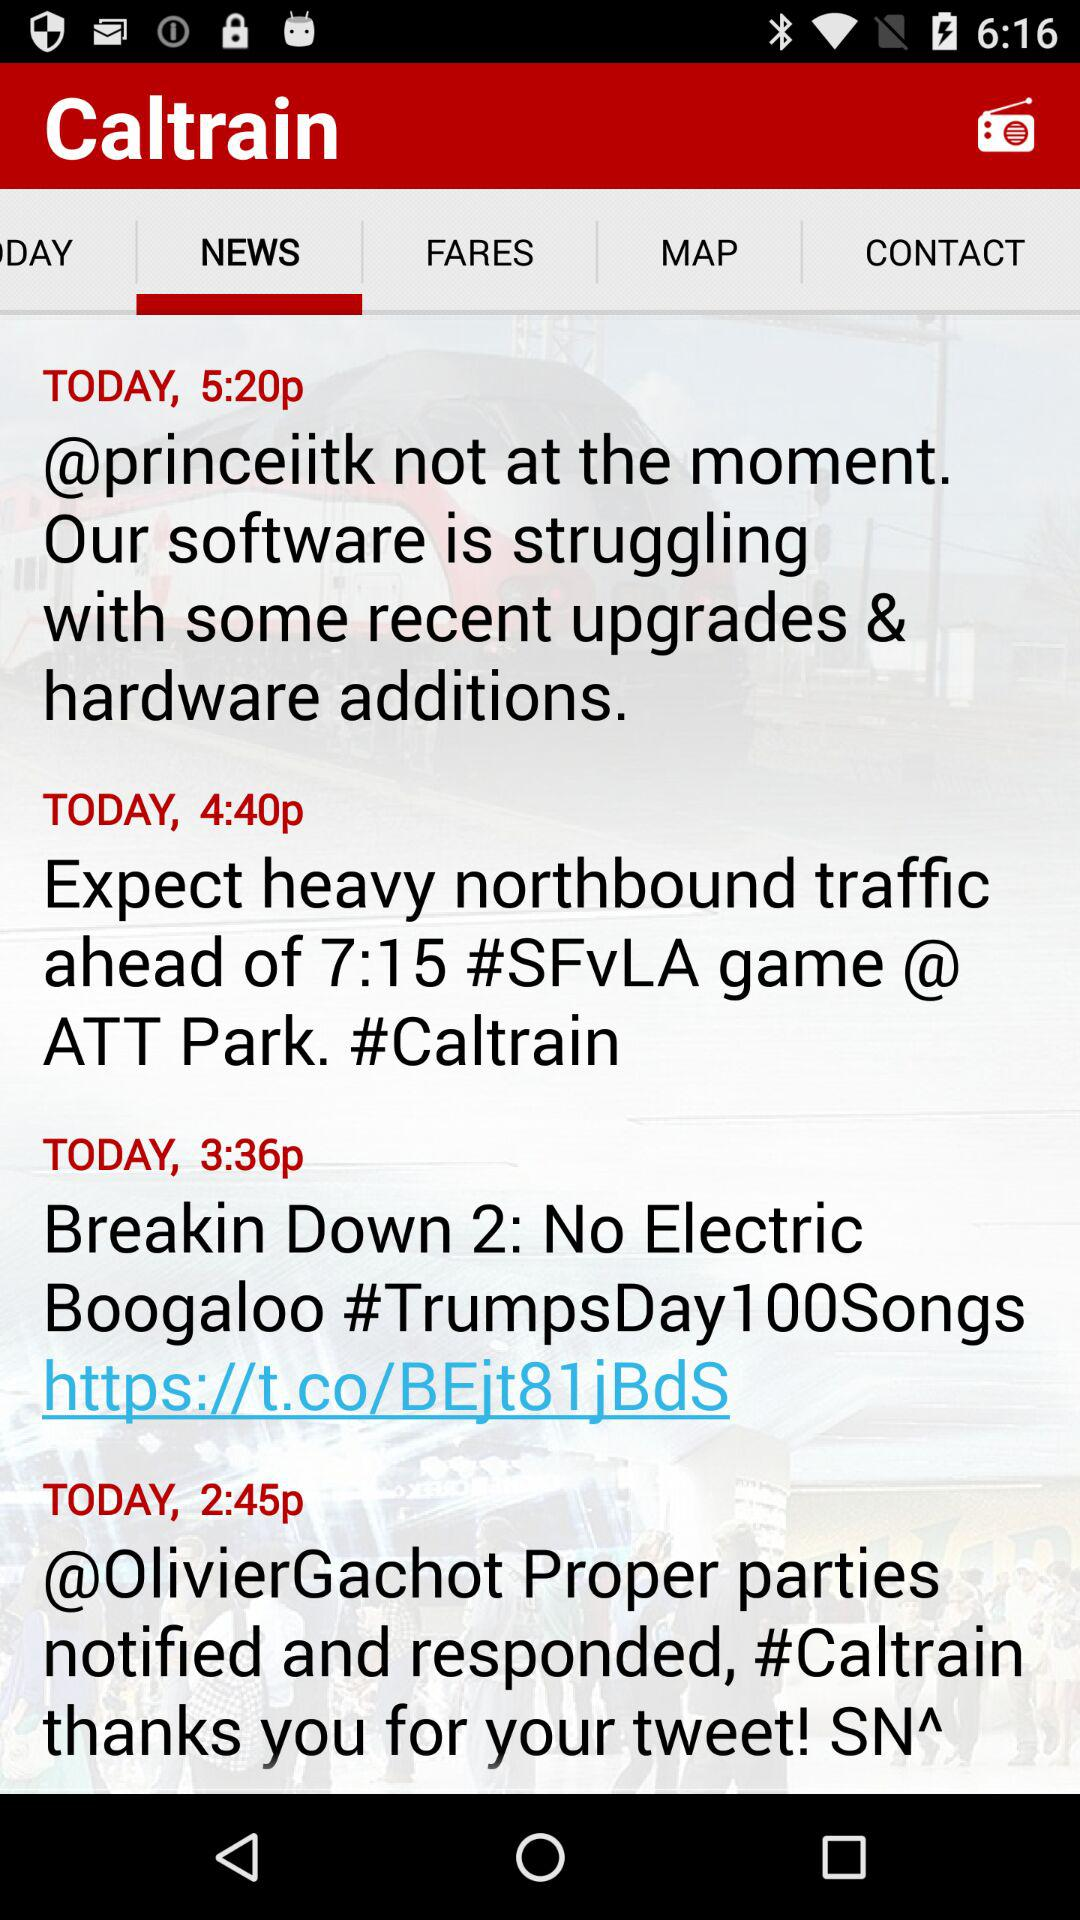What news was posted today at 3:36p?
Answer the question using a single word or phrase. The news was "Breakin Down 2: No Electric Boogaloo #TrumpsDay100Songs hhps://t.co/BEjt81jBdS" 